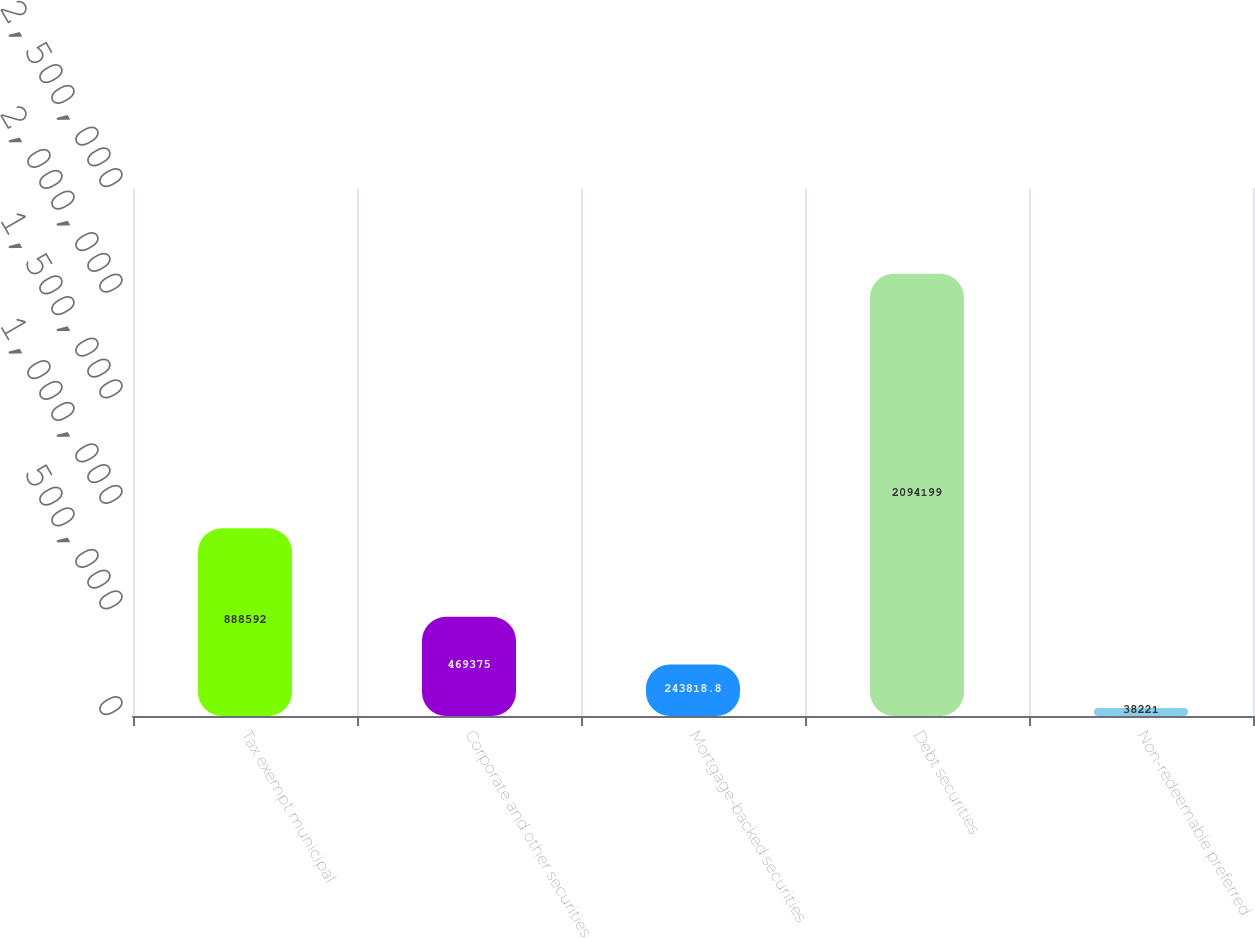Convert chart. <chart><loc_0><loc_0><loc_500><loc_500><bar_chart><fcel>Tax exempt municipal<fcel>Corporate and other securities<fcel>Mortgage-backed securities<fcel>Debt securities<fcel>Non-redeemable preferred<nl><fcel>888592<fcel>469375<fcel>243819<fcel>2.0942e+06<fcel>38221<nl></chart> 